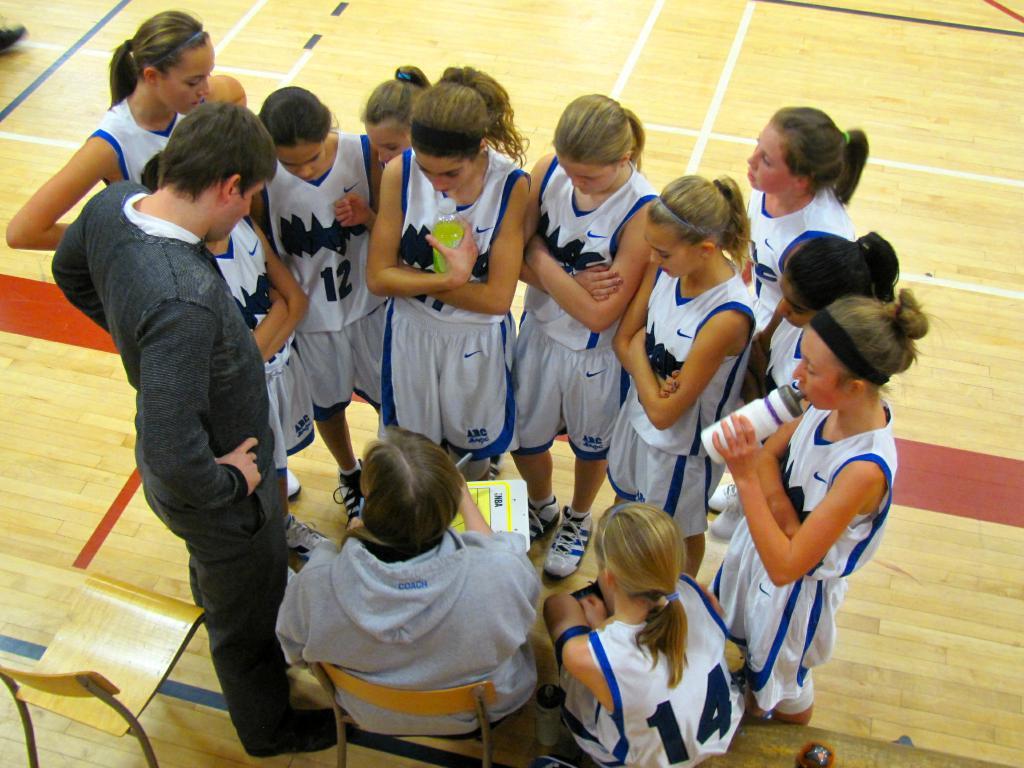What word is embroidered on the grey hoodie?
Provide a succinct answer. Coach. 